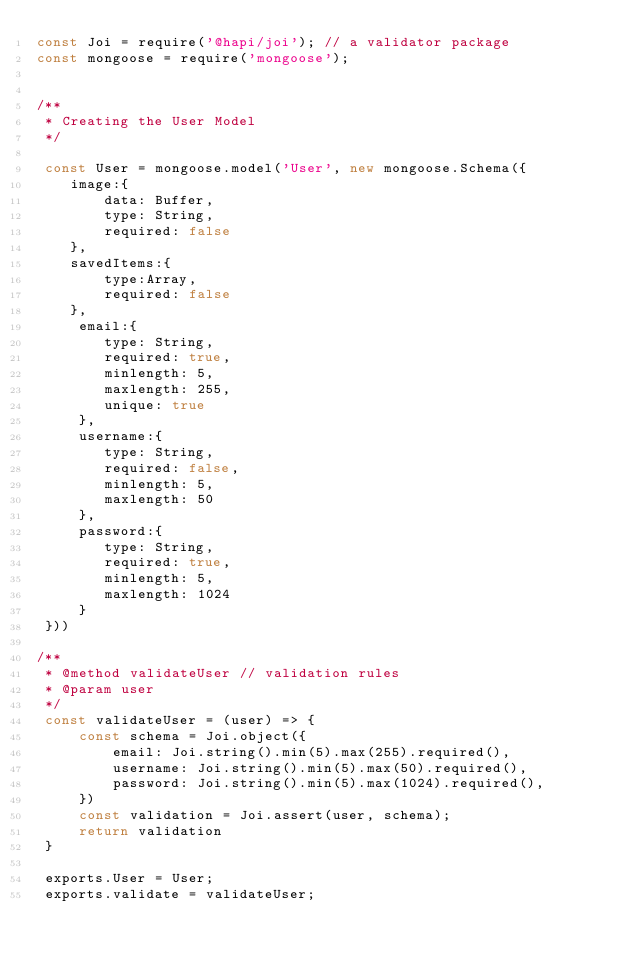Convert code to text. <code><loc_0><loc_0><loc_500><loc_500><_JavaScript_>const Joi = require('@hapi/joi'); // a validator package
const mongoose = require('mongoose');


/**
 * Creating the User Model
 */

 const User = mongoose.model('User', new mongoose.Schema({
    image:{
        data: Buffer, 
        type: String,
        required: false
    },
    savedItems:{
        type:Array,
        required: false
    },
     email:{
        type: String,
        required: true,
        minlength: 5,
        maxlength: 255,
        unique: true
     },
     username:{
        type: String,
        required: false,
        minlength: 5,
        maxlength: 50
     },
     password:{
        type: String,
        required: true,
        minlength: 5,
        maxlength: 1024
     }
 }))

/**
 * @method validateUser // validation rules
 * @param user
 */
 const validateUser = (user) => {
     const schema = Joi.object({
         email: Joi.string().min(5).max(255).required(),
         username: Joi.string().min(5).max(50).required(),
         password: Joi.string().min(5).max(1024).required(),
     })
     const validation = Joi.assert(user, schema);
     return validation
 }

 exports.User = User;
 exports.validate = validateUser;</code> 